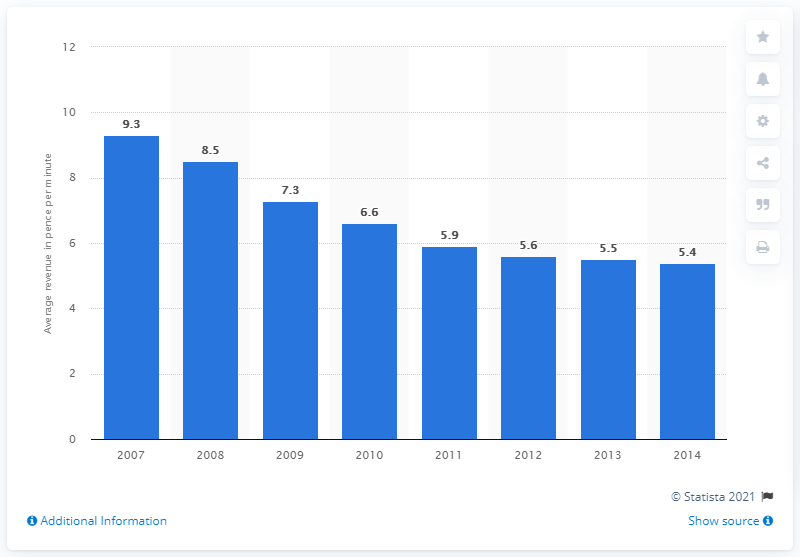List a handful of essential elements in this visual. In the year 2013, the average revenue per fixed voice call minute of international calls was 5.5 pence per minute. 